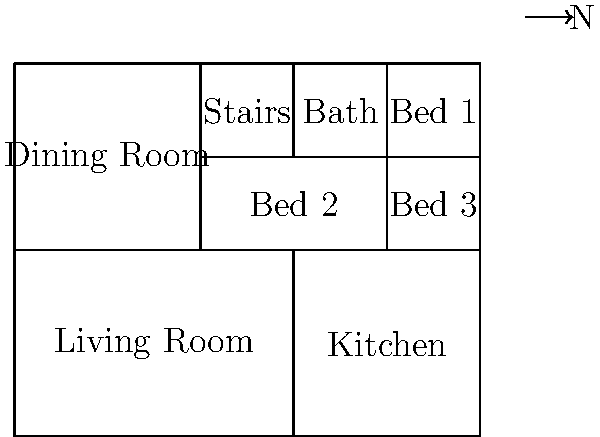Based on the aerial view of the Simpsons' house floor plan shown above, which room is located in the southwest corner of the house? To determine the room in the southwest corner of the Simpsons' house, we need to follow these steps:

1. Identify the orientation of the house using the compass rose. The arrow points north, so we can determine the other directions.

2. Locate the southwest corner. This would be the bottom-left corner of the floor plan.

3. Examine the room occupying this corner:
   - It's a large rectangular space
   - It's labeled "Living Room"
   - It takes up most of the southern (bottom) part of the house and extends to the western (left) side

4. Confirm that this room is indeed the Living Room by checking its position relative to other rooms:
   - It's adjacent to the Kitchen on the right
   - It's below the Dining Room
   - It occupies the largest single space in the house, which is typical for a living room

5. Double-check that no other room could be considered in the southwest corner. The Living Room is the only room that extends to both the southernmost and westernmost edges of the house.

Therefore, the room located in the southwest corner of the Simpsons' house is the Living Room.
Answer: Living Room 